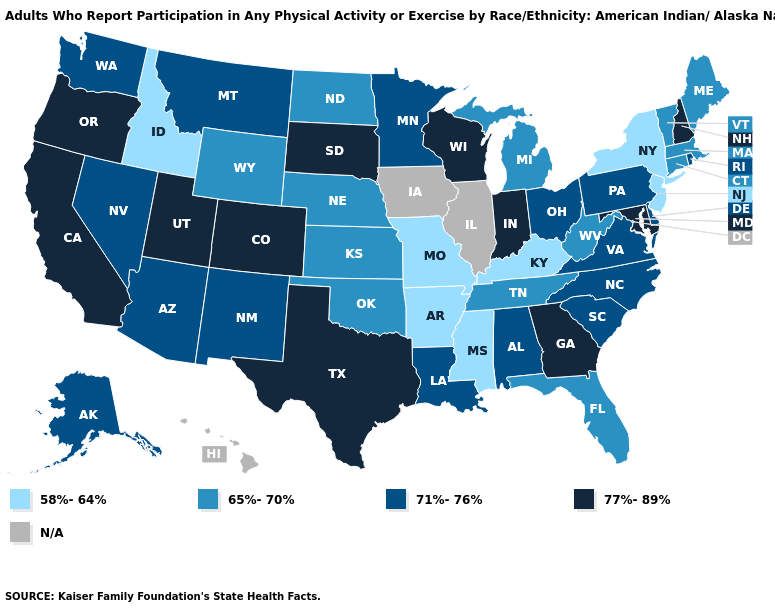Name the states that have a value in the range N/A?
Write a very short answer. Hawaii, Illinois, Iowa. How many symbols are there in the legend?
Answer briefly. 5. Does Missouri have the lowest value in the MidWest?
Be succinct. Yes. Name the states that have a value in the range 58%-64%?
Give a very brief answer. Arkansas, Idaho, Kentucky, Mississippi, Missouri, New Jersey, New York. Name the states that have a value in the range 77%-89%?
Be succinct. California, Colorado, Georgia, Indiana, Maryland, New Hampshire, Oregon, South Dakota, Texas, Utah, Wisconsin. Name the states that have a value in the range 65%-70%?
Give a very brief answer. Connecticut, Florida, Kansas, Maine, Massachusetts, Michigan, Nebraska, North Dakota, Oklahoma, Tennessee, Vermont, West Virginia, Wyoming. What is the value of California?
Keep it brief. 77%-89%. Name the states that have a value in the range 71%-76%?
Concise answer only. Alabama, Alaska, Arizona, Delaware, Louisiana, Minnesota, Montana, Nevada, New Mexico, North Carolina, Ohio, Pennsylvania, Rhode Island, South Carolina, Virginia, Washington. Among the states that border Mississippi , does Louisiana have the lowest value?
Keep it brief. No. Among the states that border Florida , which have the highest value?
Answer briefly. Georgia. Does Indiana have the highest value in the MidWest?
Concise answer only. Yes. What is the highest value in the USA?
Be succinct. 77%-89%. 